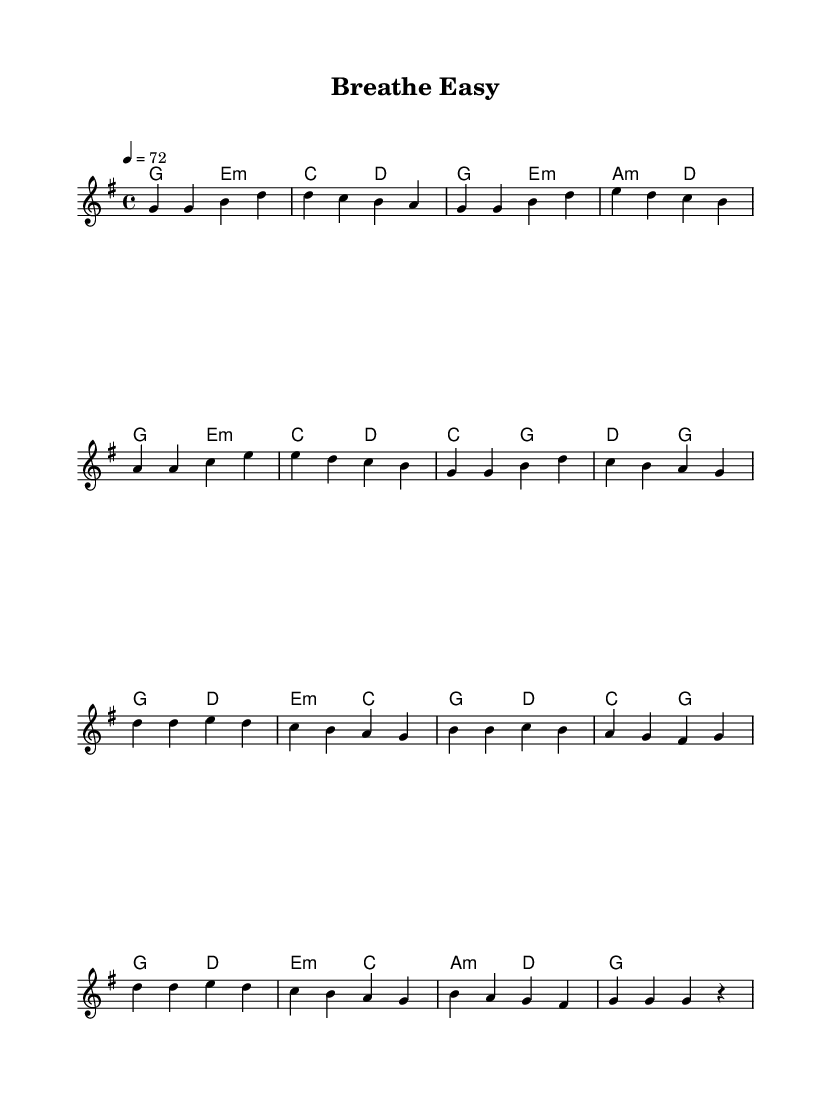What is the key signature of this music? The key signature shown is G major, which has one sharp (F#). This can be deduced from the global section of the code where "\key g \major" is specified.
Answer: G major What is the time signature of this piece? The time signature is indicated by "\time 4/4" in the global section. This means there are four beats in a measure and the quarter note gets the beat.
Answer: 4/4 What is the tempo marking for this music? The tempo is given as "4 = 72", meaning the quarter note should be played at a rate of 72 beats per minute. This is defined in the global section of the code.
Answer: 72 Which section of the music contains the chorus? The chorus section is identified in the code where the melody starts with "d'4 d e d" that is marked after the verse. The structure is implied in the comments.
Answer: Chorus How many measures are in the verse? The verse is made up of eight measures as indicated by the series of musical notes and the line endings in that section. Each line in the melody represents measures, counting to eight.
Answer: 8 What type of harmony is used in the verse? The harmony in the verse uses a mix of major and minor chords, as indicated by the chord symbols such as e:m and a:m in the harmonies section below the melody. It features simple triadic harmonies typical in K-Pop arrangements.
Answer: Major and minor chords Describe the overall mood suggested by the title "Breathe Easy." The title implies a calming and relaxing mood, appropriate for a mellow K-Pop tune that reflects work-life balance. This is further suggested by the gentle melody and harmonies that are characteristic of easy listening music.
Answer: Calming 